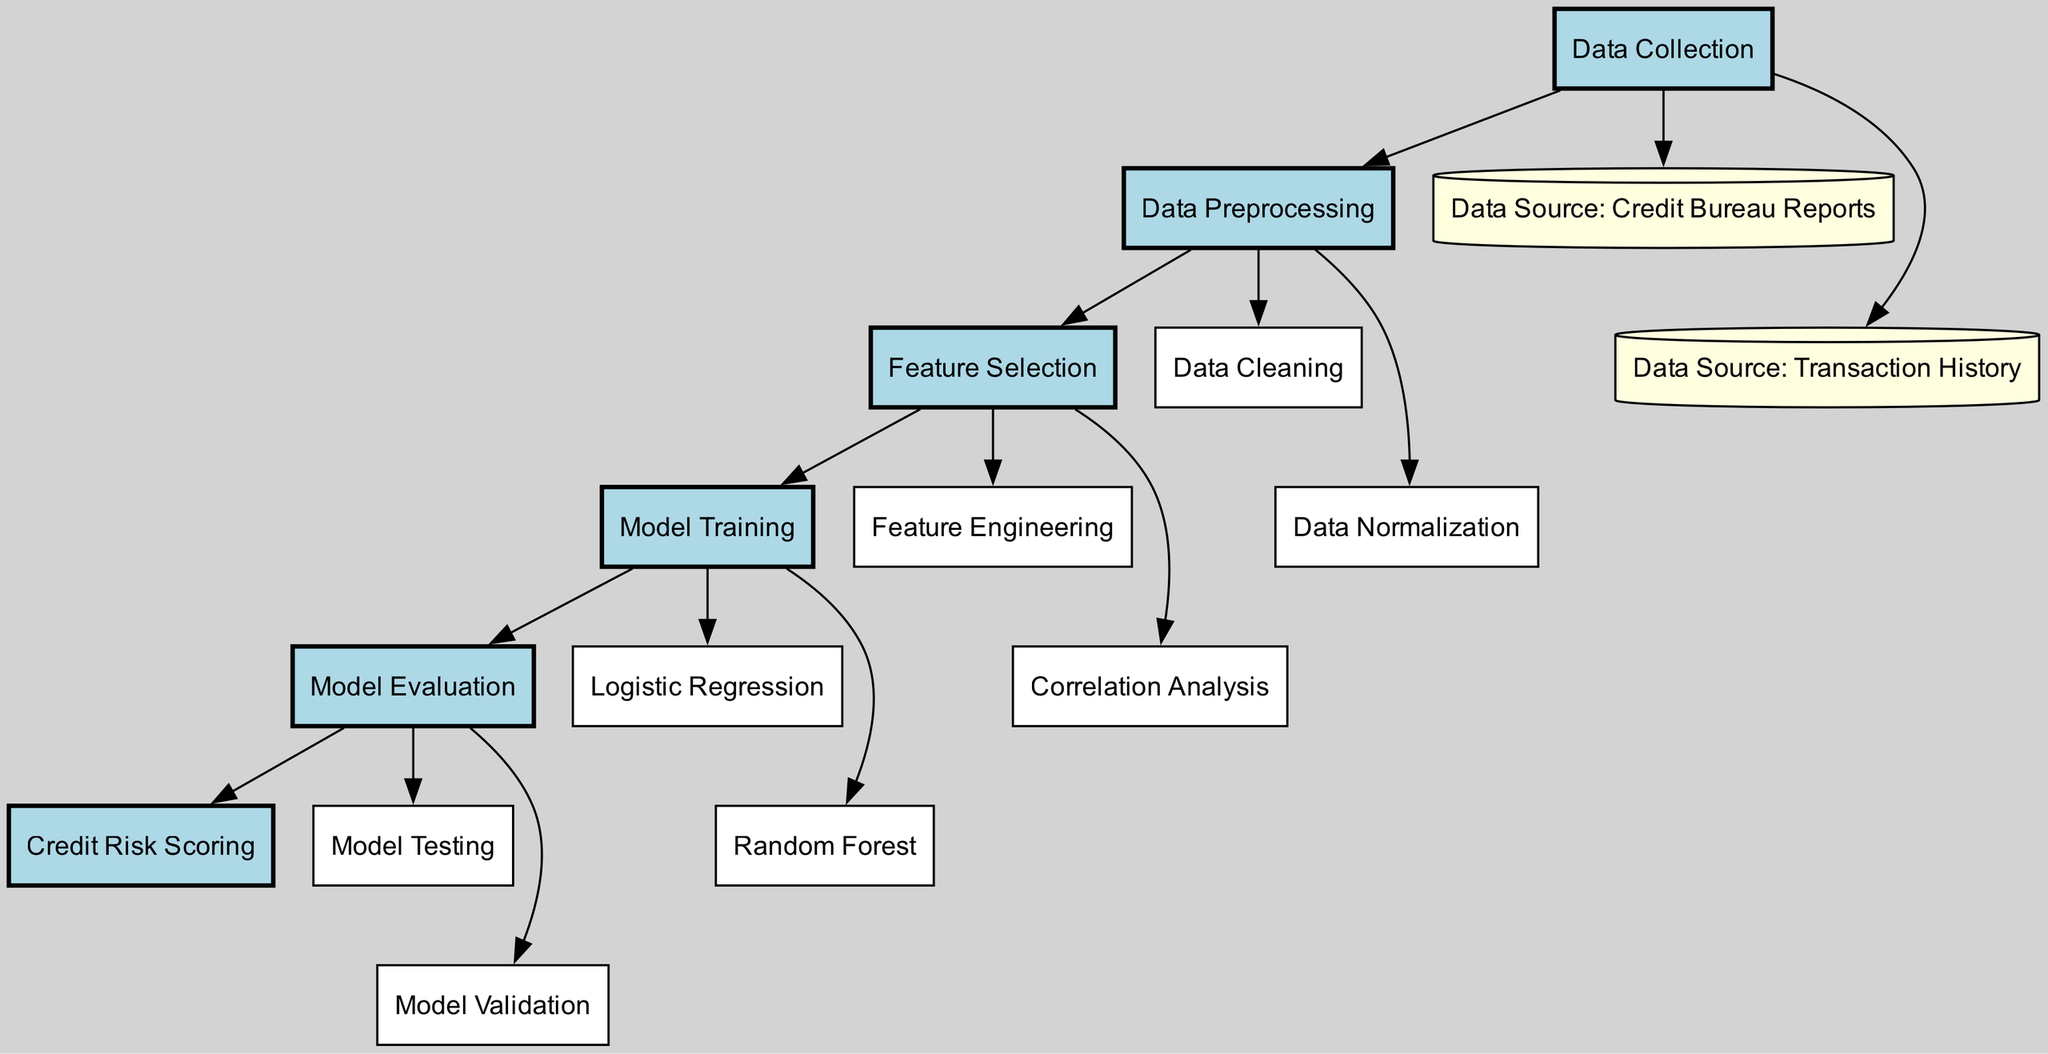What is the starting point of the diagram? The diagram begins with the node labeled "Data Collection," which is visually positioned at the top of the flowchart.
Answer: Data Collection How many data sources are indicated in the diagram? There are two data source nodes indicated: "Credit Bureau Reports" and "Transaction History." This is determined by counting the yellow cylindrical nodes that denote data sources.
Answer: 2 Which node follows the "Data Preprocessing" node? The "Feature Selection" node follows the "Data Preprocessing" node, as shown by the directed edge connecting these nodes in the diagram.
Answer: Feature Selection What type of model is indicated after the "Model Training" step? The "Logistic Regression" and "Random Forest" models are indicated following the "Model Training" step, as both are connected by edges leading from the "Model Training" node.
Answer: Logistic Regression and Random Forest What are the two tasks performed after "Model Evaluation"? The tasks that follow the "Model Evaluation" node are "Model Testing" and "Model Validation," both of which are directly connected by edges leading from the evaluation node.
Answer: Model Testing and Model Validation Which preprocessing task involves standardizing the data? "Data Normalization" is the preprocessing task that standardizes the data, represented by an edge leading from the "Data Preprocessing" node to it.
Answer: Data Normalization What is the purpose of the "Credit Risk Scoring" node? The "Credit Risk Scoring" node serves as the output of the entire process, summarizing the result of the model evaluations after training, as indicated by its position at the end of the diagram.
Answer: Credit Risk Scoring What connects "Feature Selection" to "Model Training"? The flow from "Feature Selection" to "Model Training" is connected by a directed edge, indicating that feature selection is a prerequisite for training the model.
Answer: Directed Edge Which node processes the original data to remove inaccuracies? The "Data Cleaning" node is responsible for processing the original data to remove inaccuracies, as indicated by its direct connection from the "Data Preprocessing" node.
Answer: Data Cleaning 